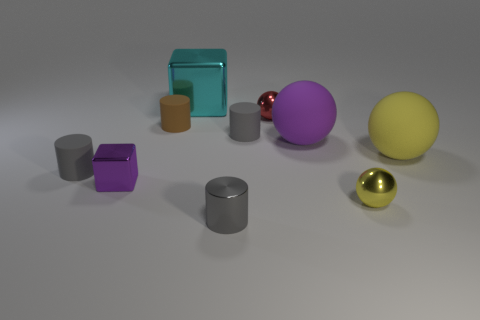The other yellow object that is the same shape as the yellow metal thing is what size?
Ensure brevity in your answer.  Large. How many tiny things are either gray matte cylinders or blue rubber things?
Ensure brevity in your answer.  2. Does the purple object that is left of the small red metallic sphere have the same material as the tiny cylinder to the left of the tiny purple shiny cube?
Offer a very short reply. No. There is a purple object that is on the left side of the brown cylinder; what material is it?
Provide a short and direct response. Metal. How many metallic things are either big cubes or tiny red balls?
Your answer should be compact. 2. There is a large matte sphere behind the ball to the right of the tiny yellow metal object; what color is it?
Provide a succinct answer. Purple. Are the brown cylinder and the tiny gray thing to the right of the small gray metal cylinder made of the same material?
Provide a short and direct response. Yes. There is a metal object that is left of the metallic block behind the gray cylinder left of the cyan thing; what is its color?
Provide a short and direct response. Purple. Is the number of large cyan metal things greater than the number of small green objects?
Your response must be concise. Yes. How many objects are in front of the small purple shiny object and on the right side of the tiny red metal sphere?
Keep it short and to the point. 1. 